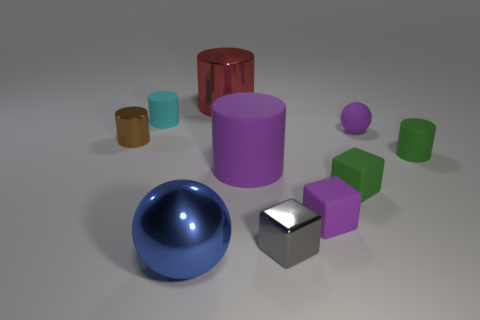Subtract all cyan cylinders. How many cylinders are left? 4 Subtract all purple cylinders. How many cylinders are left? 4 Subtract all cyan cylinders. Subtract all purple balls. How many cylinders are left? 4 Subtract all cubes. How many objects are left? 7 Subtract 0 gray cylinders. How many objects are left? 10 Subtract all purple things. Subtract all small brown metal cylinders. How many objects are left? 6 Add 7 small purple objects. How many small purple objects are left? 9 Add 10 tiny blue rubber cylinders. How many tiny blue rubber cylinders exist? 10 